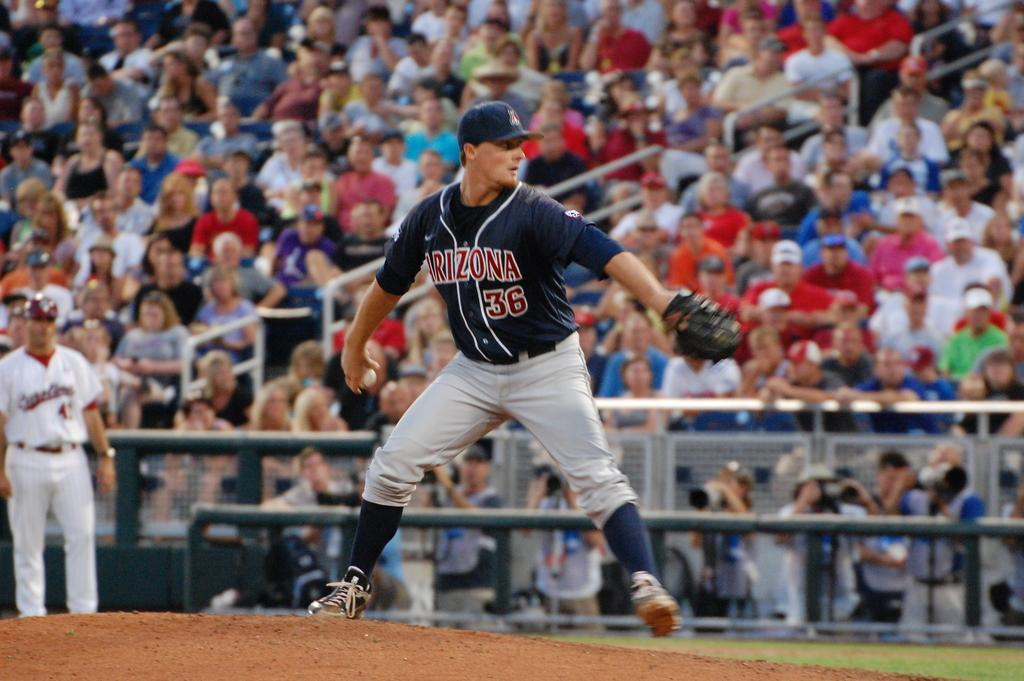<image>
Relay a brief, clear account of the picture shown. A baseball player in a gray and blue uniform has the logo for Arizona and the number 36 on his shirt. 